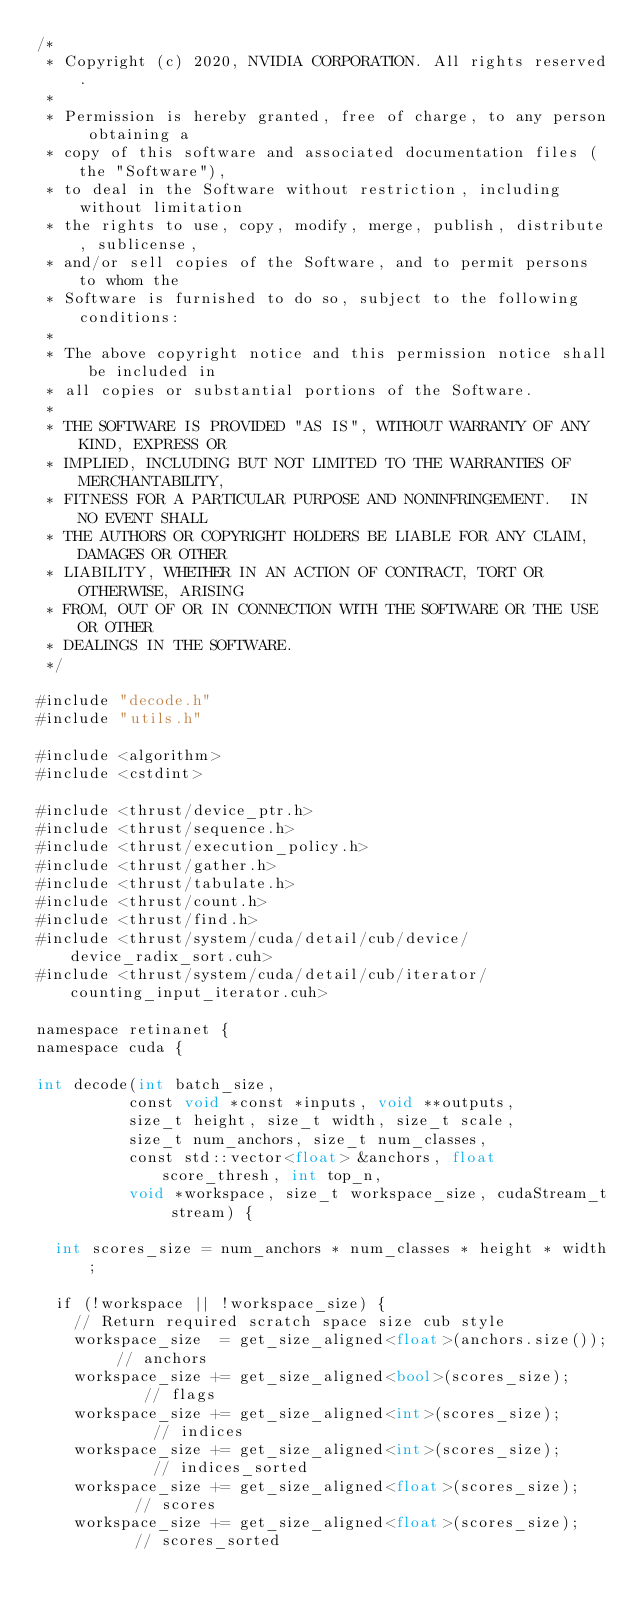Convert code to text. <code><loc_0><loc_0><loc_500><loc_500><_Cuda_>/*
 * Copyright (c) 2020, NVIDIA CORPORATION. All rights reserved.
 *
 * Permission is hereby granted, free of charge, to any person obtaining a
 * copy of this software and associated documentation files (the "Software"),
 * to deal in the Software without restriction, including without limitation
 * the rights to use, copy, modify, merge, publish, distribute, sublicense,
 * and/or sell copies of the Software, and to permit persons to whom the
 * Software is furnished to do so, subject to the following conditions:
 *
 * The above copyright notice and this permission notice shall be included in
 * all copies or substantial portions of the Software.
 *
 * THE SOFTWARE IS PROVIDED "AS IS", WITHOUT WARRANTY OF ANY KIND, EXPRESS OR
 * IMPLIED, INCLUDING BUT NOT LIMITED TO THE WARRANTIES OF MERCHANTABILITY,
 * FITNESS FOR A PARTICULAR PURPOSE AND NONINFRINGEMENT.  IN NO EVENT SHALL
 * THE AUTHORS OR COPYRIGHT HOLDERS BE LIABLE FOR ANY CLAIM, DAMAGES OR OTHER
 * LIABILITY, WHETHER IN AN ACTION OF CONTRACT, TORT OR OTHERWISE, ARISING
 * FROM, OUT OF OR IN CONNECTION WITH THE SOFTWARE OR THE USE OR OTHER
 * DEALINGS IN THE SOFTWARE.
 */

#include "decode.h"
#include "utils.h"

#include <algorithm>
#include <cstdint>

#include <thrust/device_ptr.h>
#include <thrust/sequence.h>
#include <thrust/execution_policy.h>
#include <thrust/gather.h>
#include <thrust/tabulate.h>
#include <thrust/count.h>
#include <thrust/find.h>
#include <thrust/system/cuda/detail/cub/device/device_radix_sort.cuh>
#include <thrust/system/cuda/detail/cub/iterator/counting_input_iterator.cuh>

namespace retinanet {
namespace cuda {

int decode(int batch_size,
          const void *const *inputs, void **outputs,
          size_t height, size_t width, size_t scale,
          size_t num_anchors, size_t num_classes,
          const std::vector<float> &anchors, float score_thresh, int top_n,
          void *workspace, size_t workspace_size, cudaStream_t stream) {

  int scores_size = num_anchors * num_classes * height * width;
  
  if (!workspace || !workspace_size) {
    // Return required scratch space size cub style
    workspace_size  = get_size_aligned<float>(anchors.size()); // anchors
    workspace_size += get_size_aligned<bool>(scores_size);     // flags
    workspace_size += get_size_aligned<int>(scores_size);      // indices
    workspace_size += get_size_aligned<int>(scores_size);      // indices_sorted
    workspace_size += get_size_aligned<float>(scores_size);    // scores
    workspace_size += get_size_aligned<float>(scores_size);    // scores_sorted
  </code> 